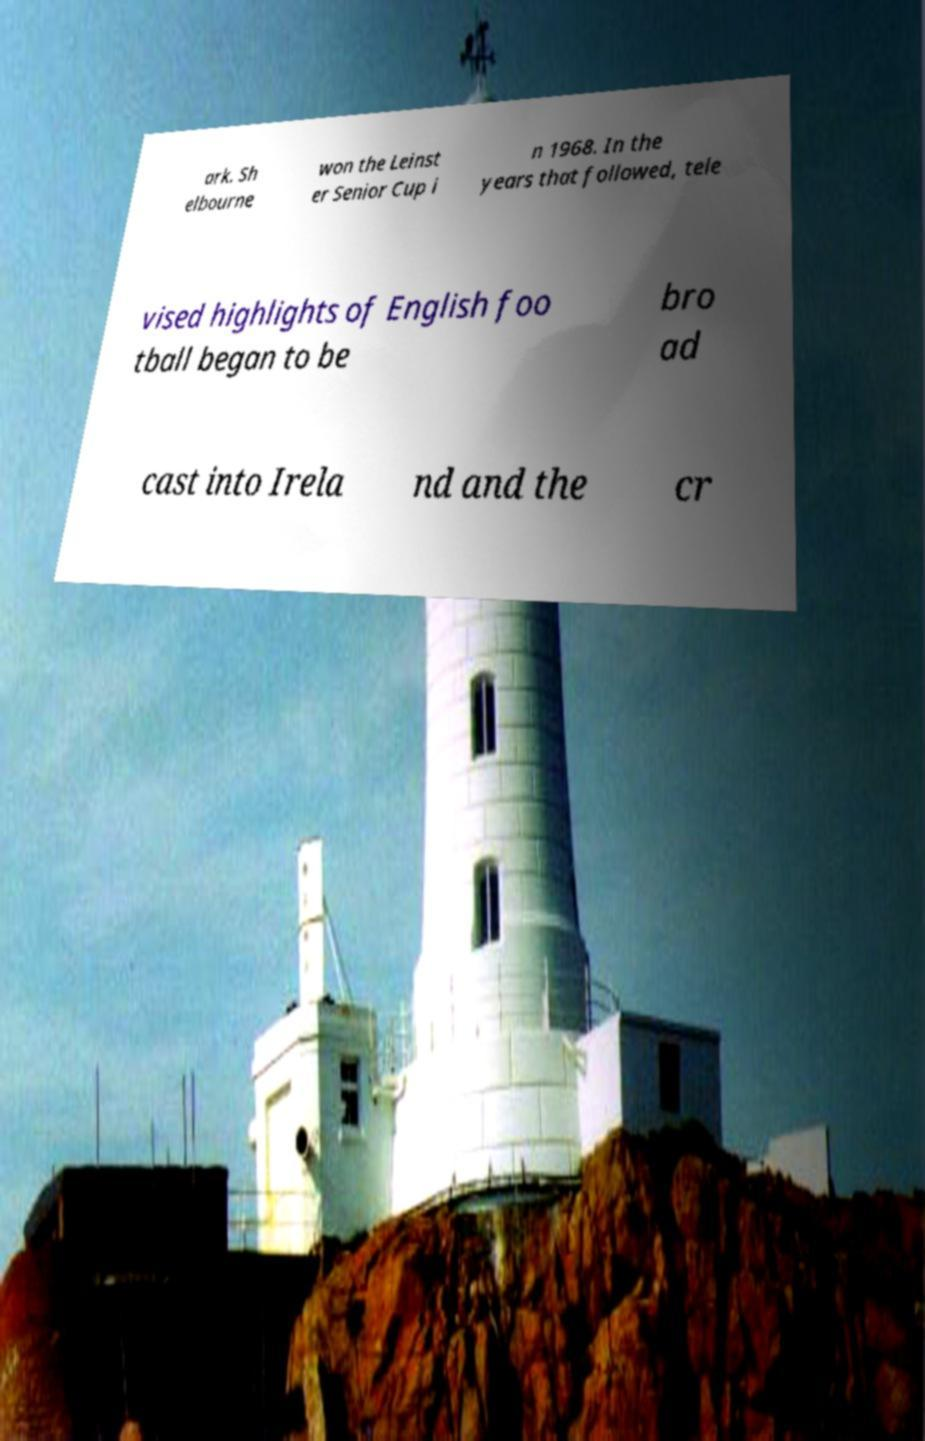I need the written content from this picture converted into text. Can you do that? ark. Sh elbourne won the Leinst er Senior Cup i n 1968. In the years that followed, tele vised highlights of English foo tball began to be bro ad cast into Irela nd and the cr 